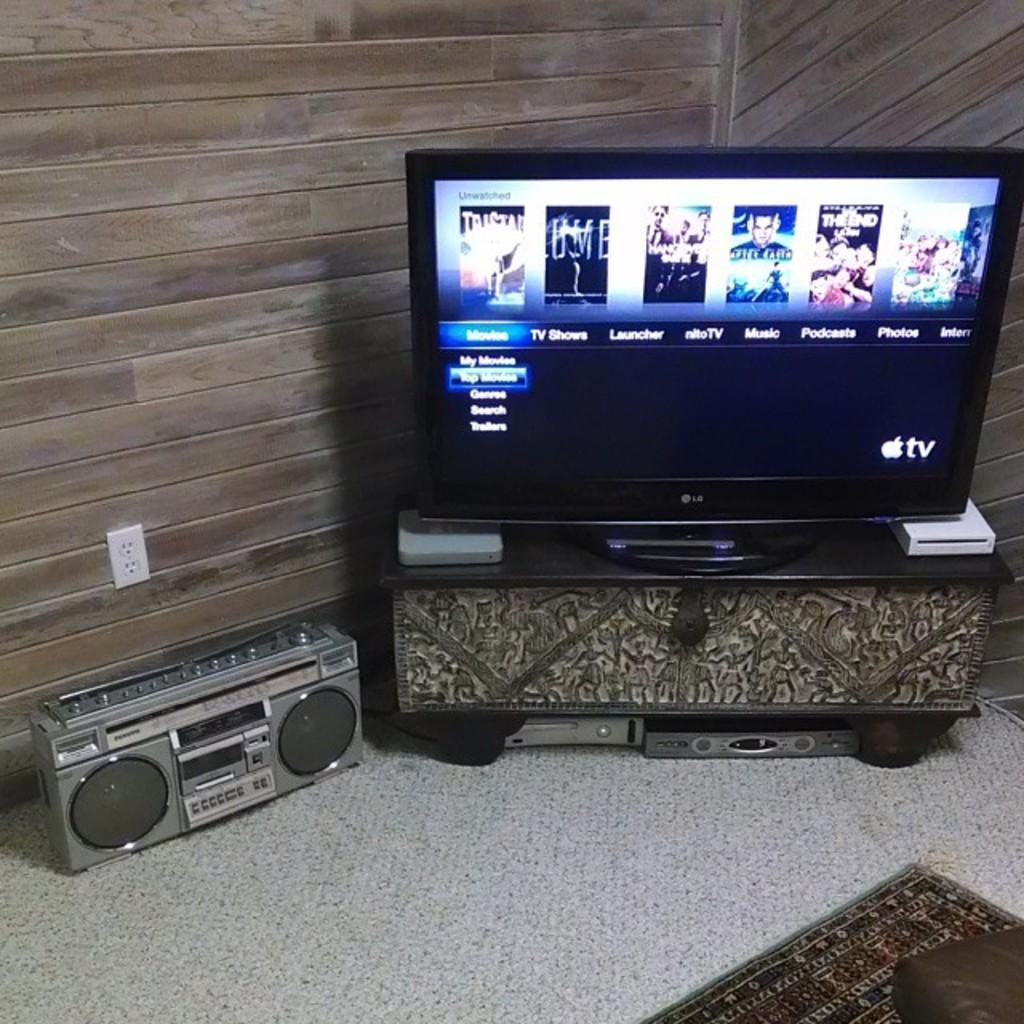<image>
Relay a brief, clear account of the picture shown. A wide screen television displays an Apple TV menu page. 